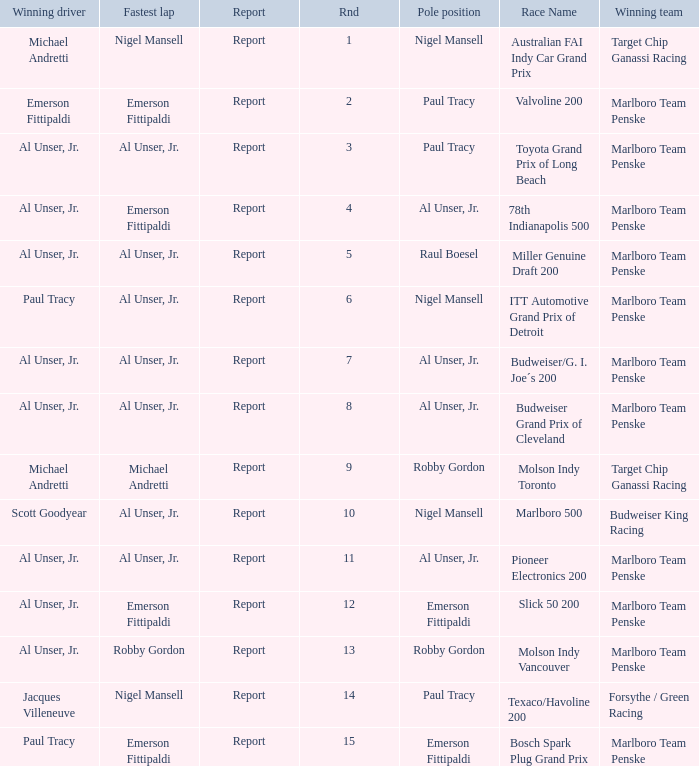Who was at the pole position in the ITT Automotive Grand Prix of Detroit, won by Paul Tracy? Nigel Mansell. 